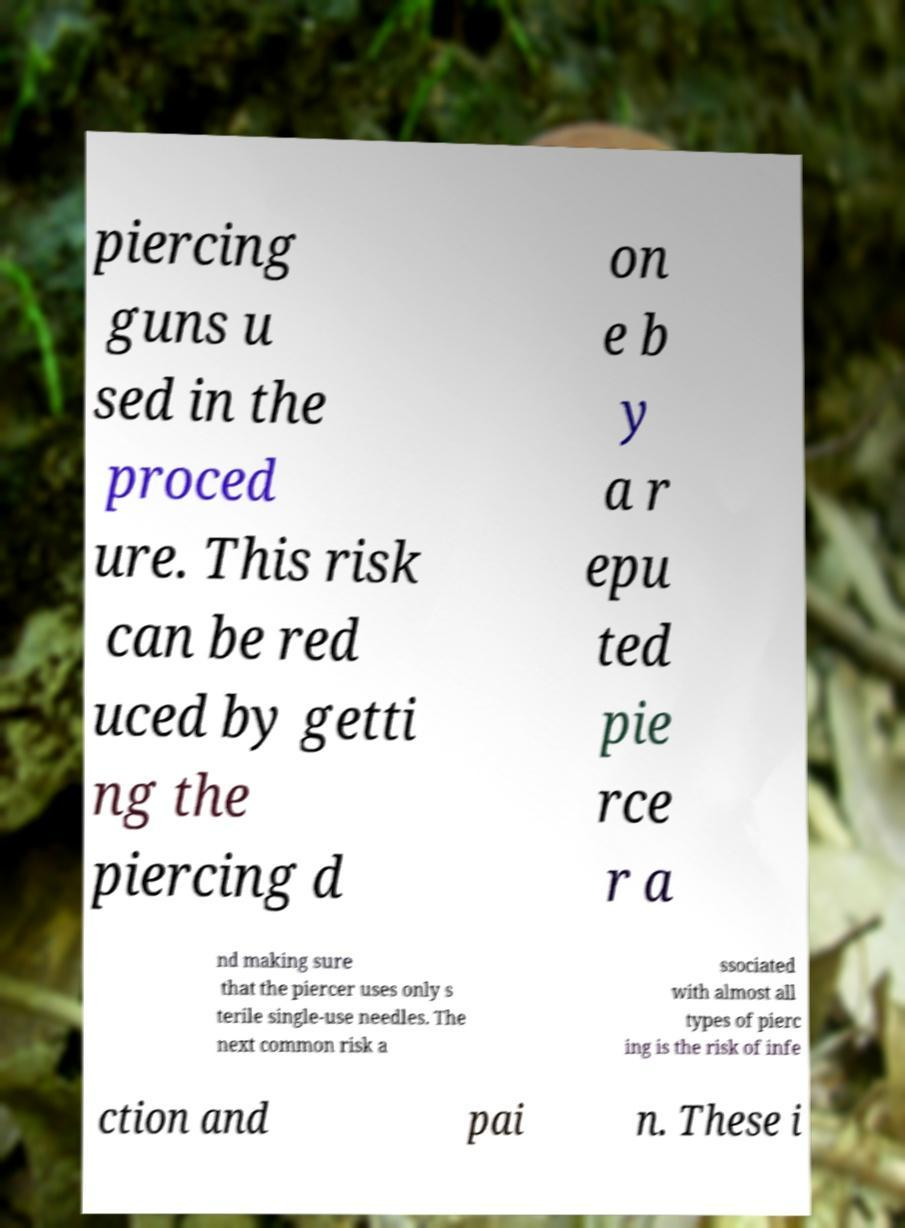Please identify and transcribe the text found in this image. piercing guns u sed in the proced ure. This risk can be red uced by getti ng the piercing d on e b y a r epu ted pie rce r a nd making sure that the piercer uses only s terile single-use needles. The next common risk a ssociated with almost all types of pierc ing is the risk of infe ction and pai n. These i 